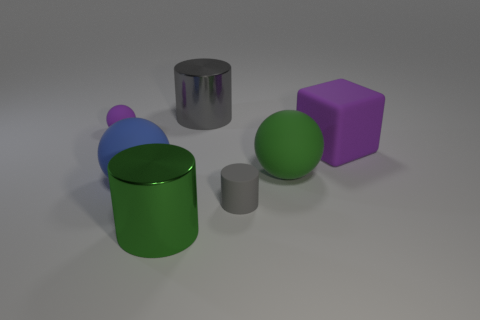Subtract 1 balls. How many balls are left? 2 Subtract all green spheres. How many spheres are left? 2 Subtract all cylinders. How many objects are left? 4 Add 3 big green rubber cylinders. How many objects exist? 10 Subtract all green cylinders. How many cylinders are left? 2 Subtract 0 brown cubes. How many objects are left? 7 Subtract all gray blocks. Subtract all cyan spheres. How many blocks are left? 1 Subtract all yellow cylinders. How many yellow spheres are left? 0 Subtract all yellow metal things. Subtract all green matte balls. How many objects are left? 6 Add 1 purple matte objects. How many purple matte objects are left? 3 